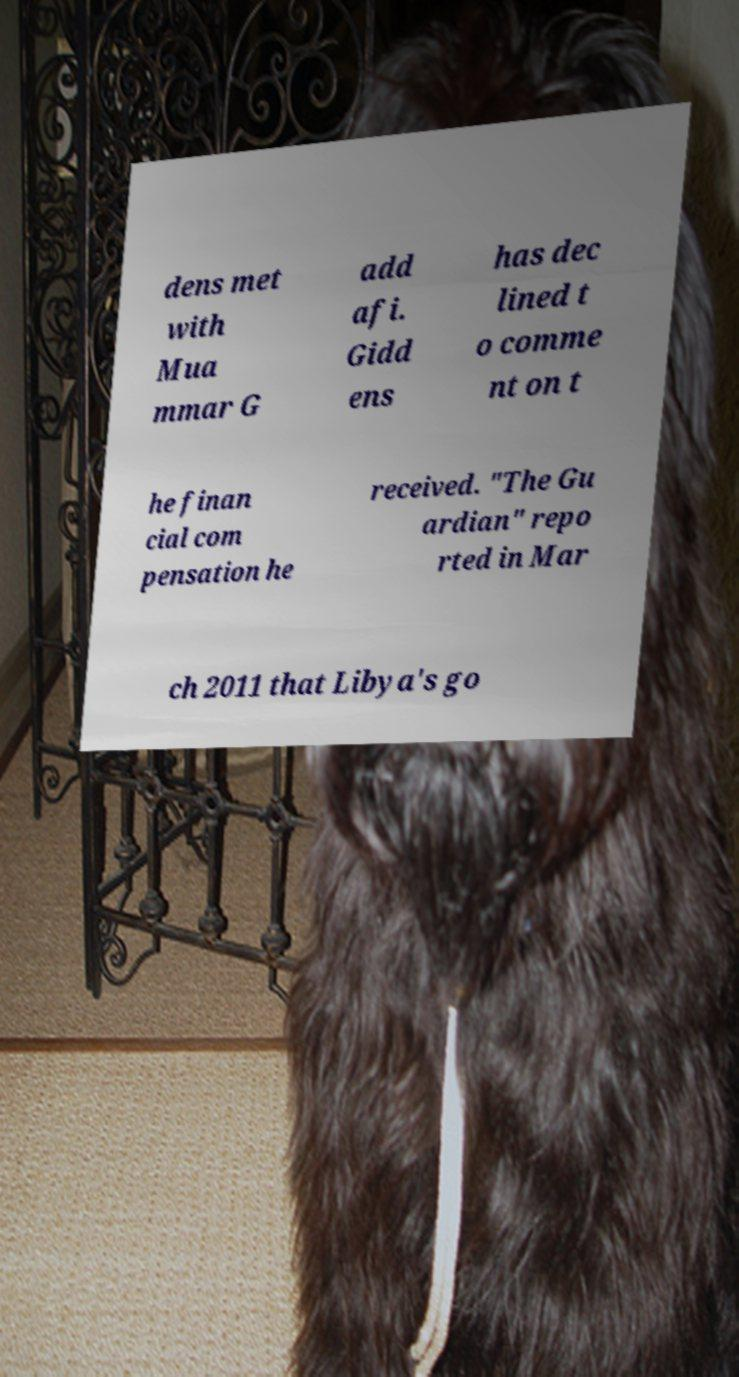Please read and relay the text visible in this image. What does it say? dens met with Mua mmar G add afi. Gidd ens has dec lined t o comme nt on t he finan cial com pensation he received. "The Gu ardian" repo rted in Mar ch 2011 that Libya's go 